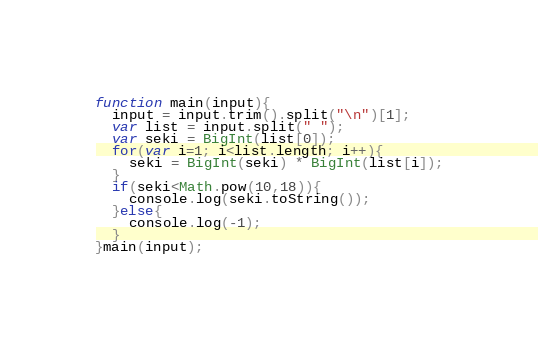<code> <loc_0><loc_0><loc_500><loc_500><_JavaScript_>function main(input){
  input = input.trim().split("\n")[1];
  var list = input.split(" ");
  var seki = BigInt(list[0]);
  for(var i=1; i<list.length; i++){
    seki = BigInt(seki) * BigInt(list[i]);
  }
  if(seki<Math.pow(10,18)){
    console.log(seki.toString());
  }else{
  	console.log(-1);
  }
}main(input);</code> 